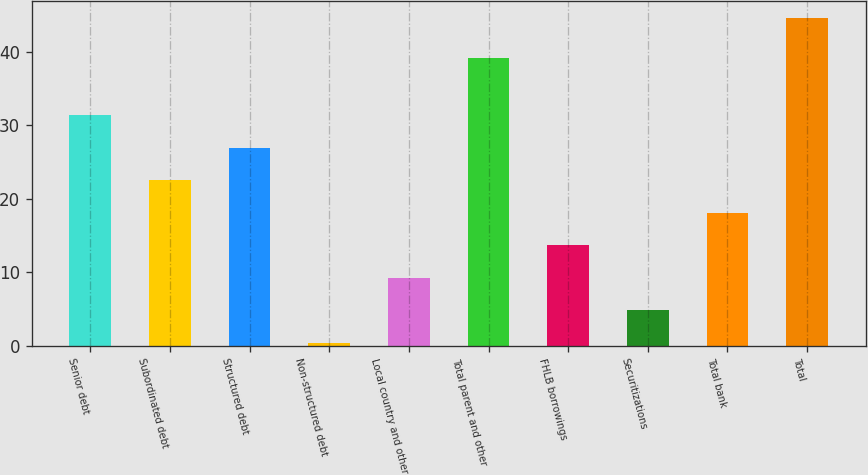Convert chart. <chart><loc_0><loc_0><loc_500><loc_500><bar_chart><fcel>Senior debt<fcel>Subordinated debt<fcel>Structured debt<fcel>Non-structured debt<fcel>Local country and other<fcel>Total parent and other<fcel>FHLB borrowings<fcel>Securitizations<fcel>Total bank<fcel>Total<nl><fcel>31.34<fcel>22.5<fcel>26.92<fcel>0.4<fcel>9.24<fcel>39.1<fcel>13.66<fcel>4.82<fcel>18.08<fcel>44.6<nl></chart> 